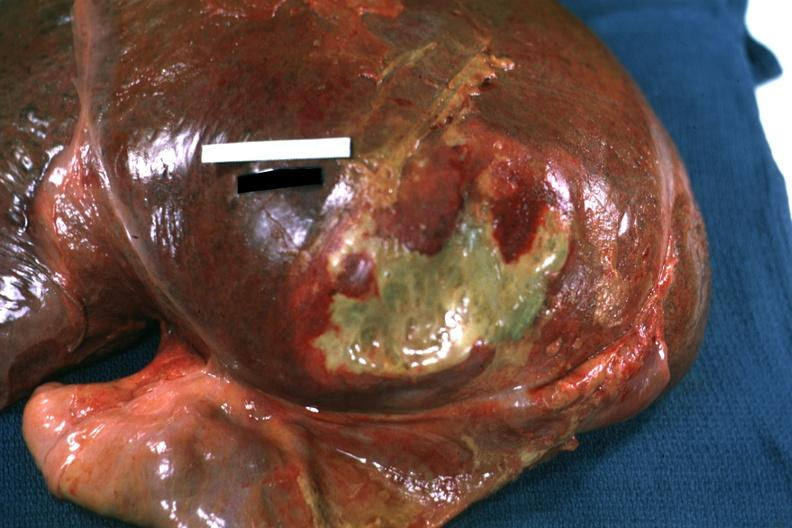s hepatobiliary present?
Answer the question using a single word or phrase. Yes 